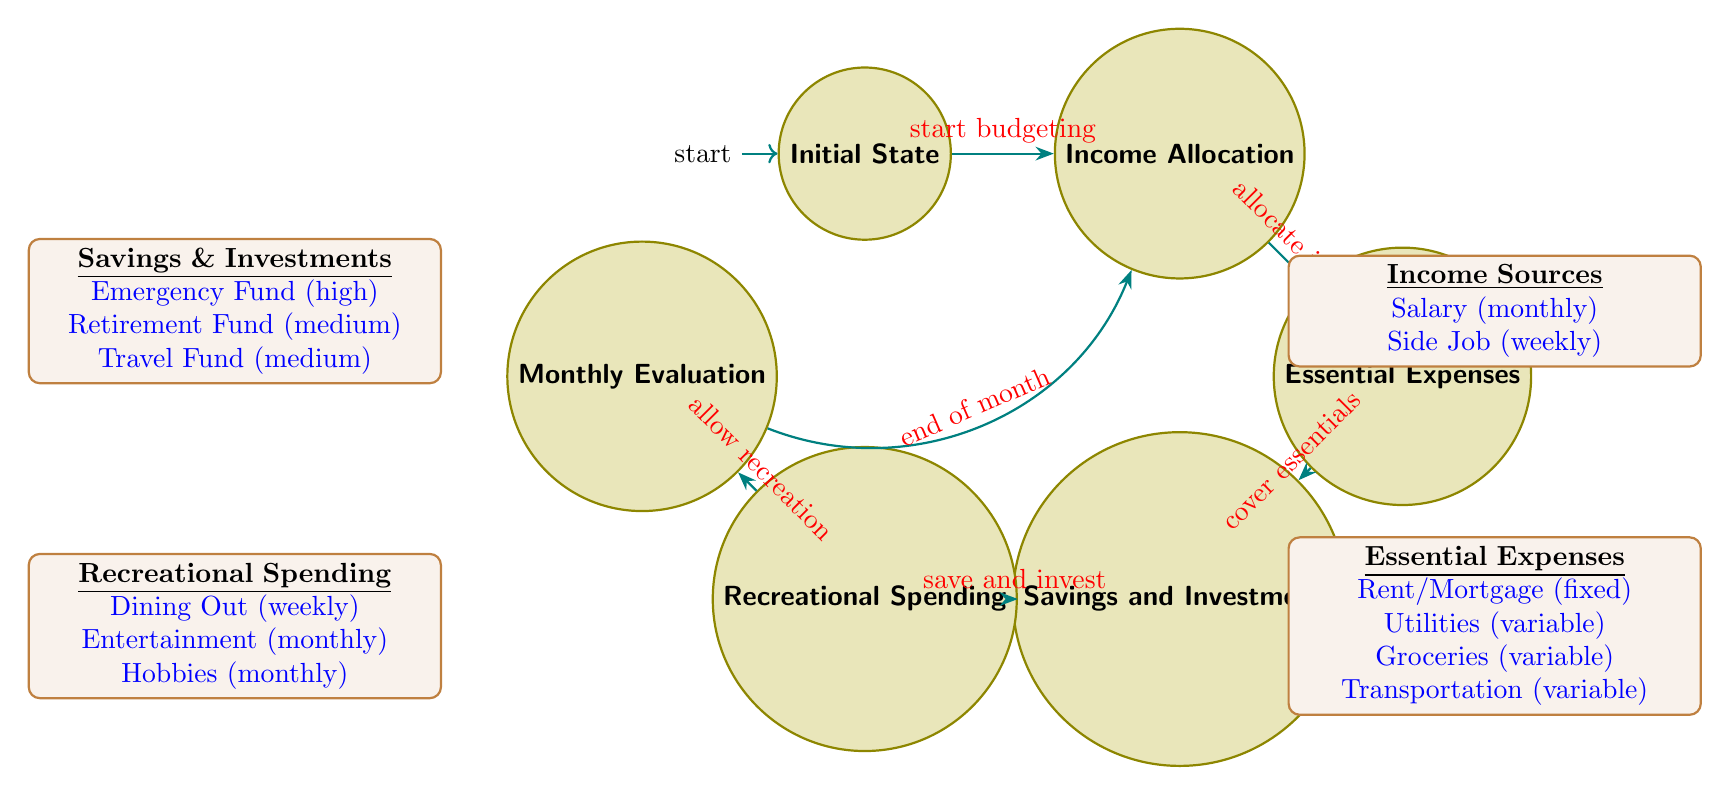What is the initial state of the budget management process? The diagram shows that the initial state is labeled "Initial State." This is the starting point of the finite state machine where the budgeting process begins.
Answer: Initial State How many total states are present in the diagram? To find the total number of states, we count each state listed in the diagram: Initial State, Income Allocation, Essential Expenses, Savings and Investments, Recreational Spending, and Monthly Evaluation. This results in a total of 6 states.
Answer: 6 What condition leads to the transition from Monthly Evaluation to Income Allocation? The diagram indicates that the transition from Monthly Evaluation to Income Allocation occurs when the condition "end of month" is met. This transitions back to the budgeting process.
Answer: end of month Which state comes after Savings and Investments? Following the flow of the diagram, after the state "Savings and Investments," the next state is "Recreational Spending," as indicated by the arrow connecting them.
Answer: Recreational Spending What is the priority of the Retirement Fund in Savings and Investments? The diagram specifies that the Retirement Fund has a priority labeled as "medium." This indicates its importance compared to other funds listed.
Answer: medium How many types of essential expenses are indicated in the diagram? Counting the types of essential expenses listed in the diagram, there are four: Rent/Mortgage, Utilities, Groceries, and Transportation, thus resulting in a total of four types.
Answer: 4 What flow occurs after covering essential expenses? After covering essential expenses, the flow goes to the next state labeled "Savings and Investments." This shows that after essentials are paid, attention shifts to savings and investment.
Answer: Savings and Investments Which transition is triggered by the condition "allow recreation"? The condition "allow recreation" triggers the transition from "Recreational Spending" to "Monthly Evaluation." This indicates a step in the budgeting process where recreation is considered.
Answer: Monthly Evaluation What is the measure for budget adherence in Monthly Evaluation? The evaluation criteria for budget adherence in the Monthly Evaluation state is measured as "percentage of adherence." This indicates how well the budget is followed throughout the month.
Answer: percentage of adherence 